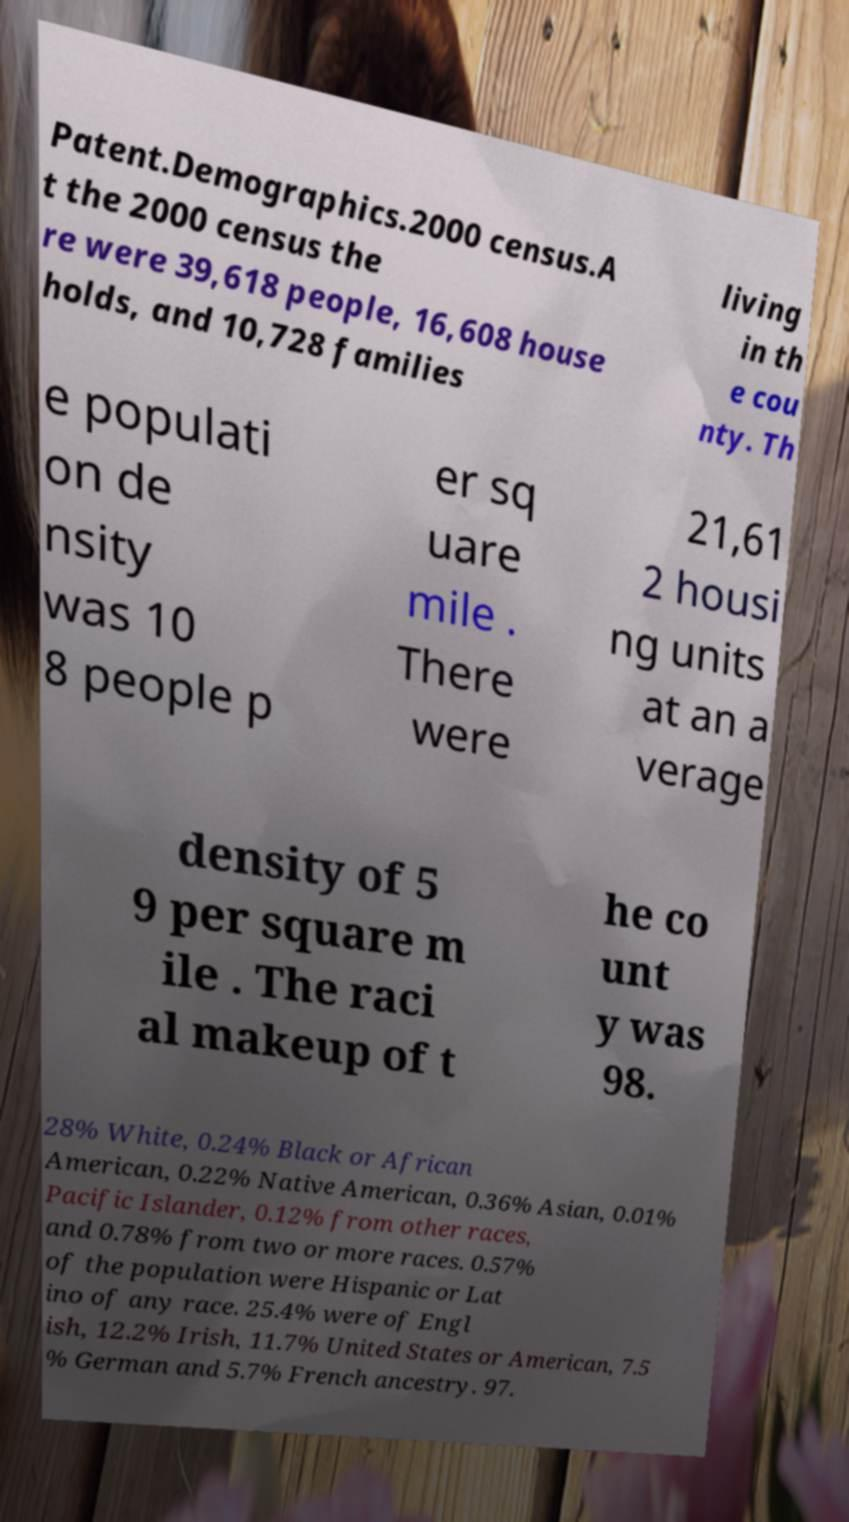Can you read and provide the text displayed in the image?This photo seems to have some interesting text. Can you extract and type it out for me? Patent.Demographics.2000 census.A t the 2000 census the re were 39,618 people, 16,608 house holds, and 10,728 families living in th e cou nty. Th e populati on de nsity was 10 8 people p er sq uare mile . There were 21,61 2 housi ng units at an a verage density of 5 9 per square m ile . The raci al makeup of t he co unt y was 98. 28% White, 0.24% Black or African American, 0.22% Native American, 0.36% Asian, 0.01% Pacific Islander, 0.12% from other races, and 0.78% from two or more races. 0.57% of the population were Hispanic or Lat ino of any race. 25.4% were of Engl ish, 12.2% Irish, 11.7% United States or American, 7.5 % German and 5.7% French ancestry. 97. 